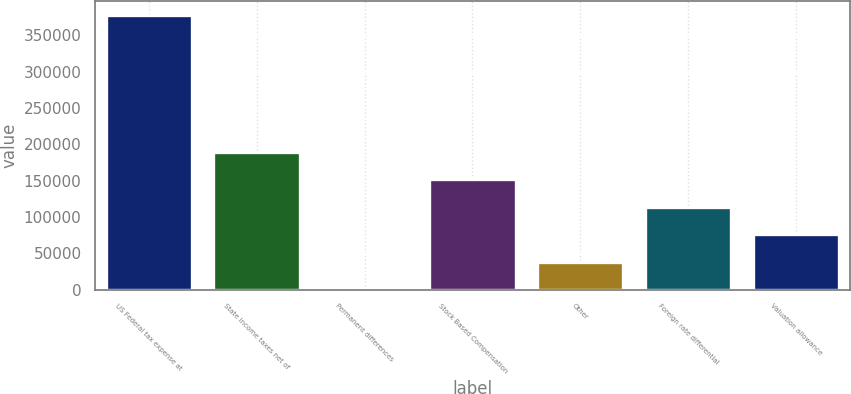Convert chart to OTSL. <chart><loc_0><loc_0><loc_500><loc_500><bar_chart><fcel>US Federal tax expense at<fcel>State income taxes net of<fcel>Permanent differences<fcel>Stock Based Compensation<fcel>Other<fcel>Foreign rate differential<fcel>Valuation allowance<nl><fcel>377599<fcel>189276<fcel>954<fcel>151612<fcel>38618.5<fcel>113948<fcel>76283<nl></chart> 